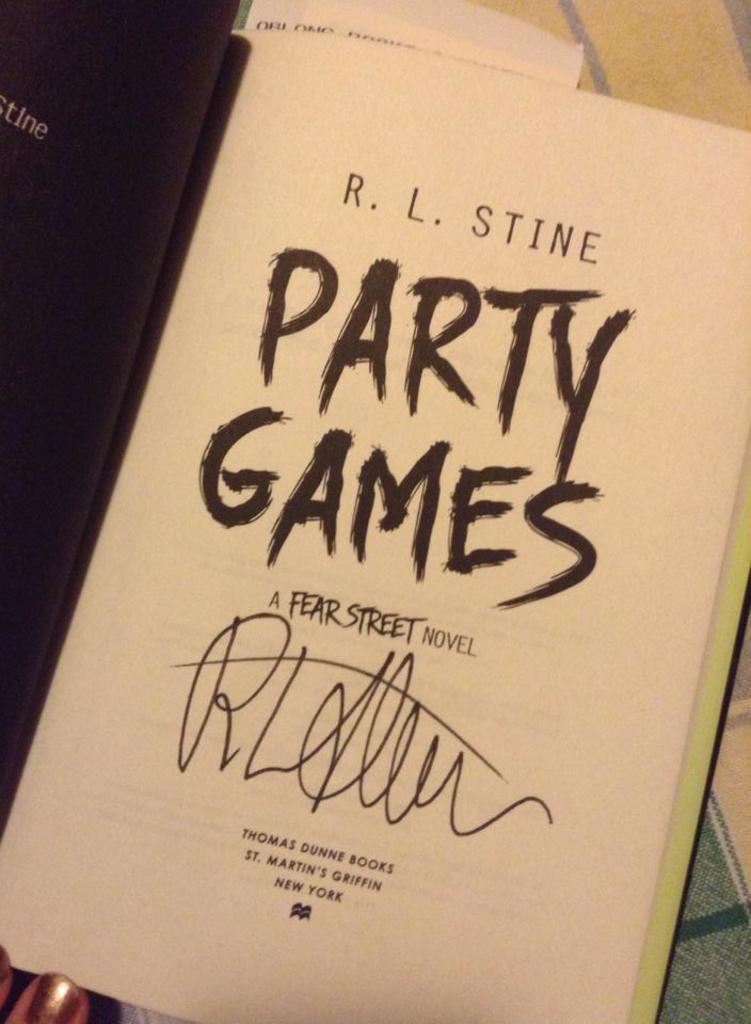<image>
Render a clear and concise summary of the photo. A party games fear street novel by R.L Stine 